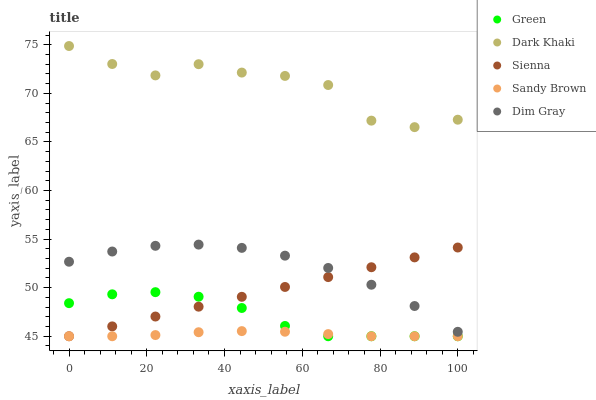Does Sandy Brown have the minimum area under the curve?
Answer yes or no. Yes. Does Dark Khaki have the maximum area under the curve?
Answer yes or no. Yes. Does Sienna have the minimum area under the curve?
Answer yes or no. No. Does Sienna have the maximum area under the curve?
Answer yes or no. No. Is Sienna the smoothest?
Answer yes or no. Yes. Is Dark Khaki the roughest?
Answer yes or no. Yes. Is Dim Gray the smoothest?
Answer yes or no. No. Is Dim Gray the roughest?
Answer yes or no. No. Does Sienna have the lowest value?
Answer yes or no. Yes. Does Dim Gray have the lowest value?
Answer yes or no. No. Does Dark Khaki have the highest value?
Answer yes or no. Yes. Does Sienna have the highest value?
Answer yes or no. No. Is Sienna less than Dark Khaki?
Answer yes or no. Yes. Is Dim Gray greater than Green?
Answer yes or no. Yes. Does Green intersect Sienna?
Answer yes or no. Yes. Is Green less than Sienna?
Answer yes or no. No. Is Green greater than Sienna?
Answer yes or no. No. Does Sienna intersect Dark Khaki?
Answer yes or no. No. 